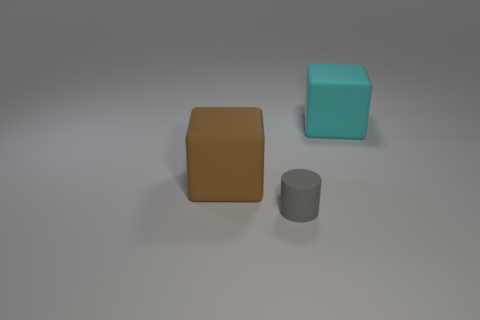Add 3 large things. How many objects exist? 6 Subtract all cyan cubes. How many cubes are left? 1 Subtract 1 blocks. How many blocks are left? 1 Subtract all cubes. How many objects are left? 1 Subtract all yellow blocks. How many red cylinders are left? 0 Subtract all tiny matte cylinders. Subtract all small green objects. How many objects are left? 2 Add 1 gray cylinders. How many gray cylinders are left? 2 Add 2 cyan blocks. How many cyan blocks exist? 3 Subtract 0 brown cylinders. How many objects are left? 3 Subtract all cyan cylinders. Subtract all blue spheres. How many cylinders are left? 1 